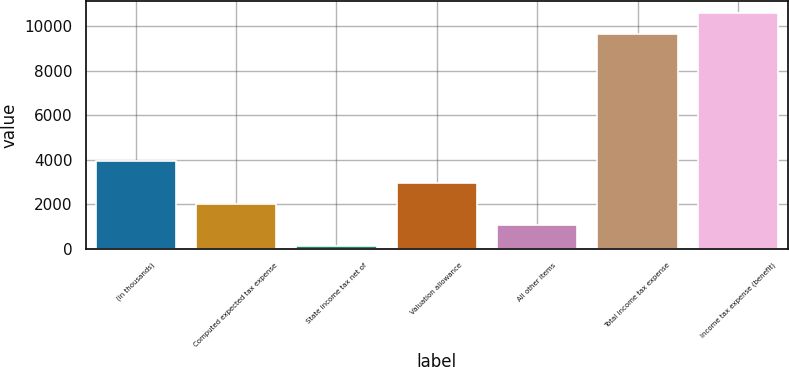Convert chart. <chart><loc_0><loc_0><loc_500><loc_500><bar_chart><fcel>(in thousands)<fcel>Computed expected tax expense<fcel>State income tax net of<fcel>Valuation allowance<fcel>All other items<fcel>Total income tax expense<fcel>Income tax expense (benefit)<nl><fcel>3923.6<fcel>2015.8<fcel>108<fcel>2969.7<fcel>1061.9<fcel>9647<fcel>10600.9<nl></chart> 